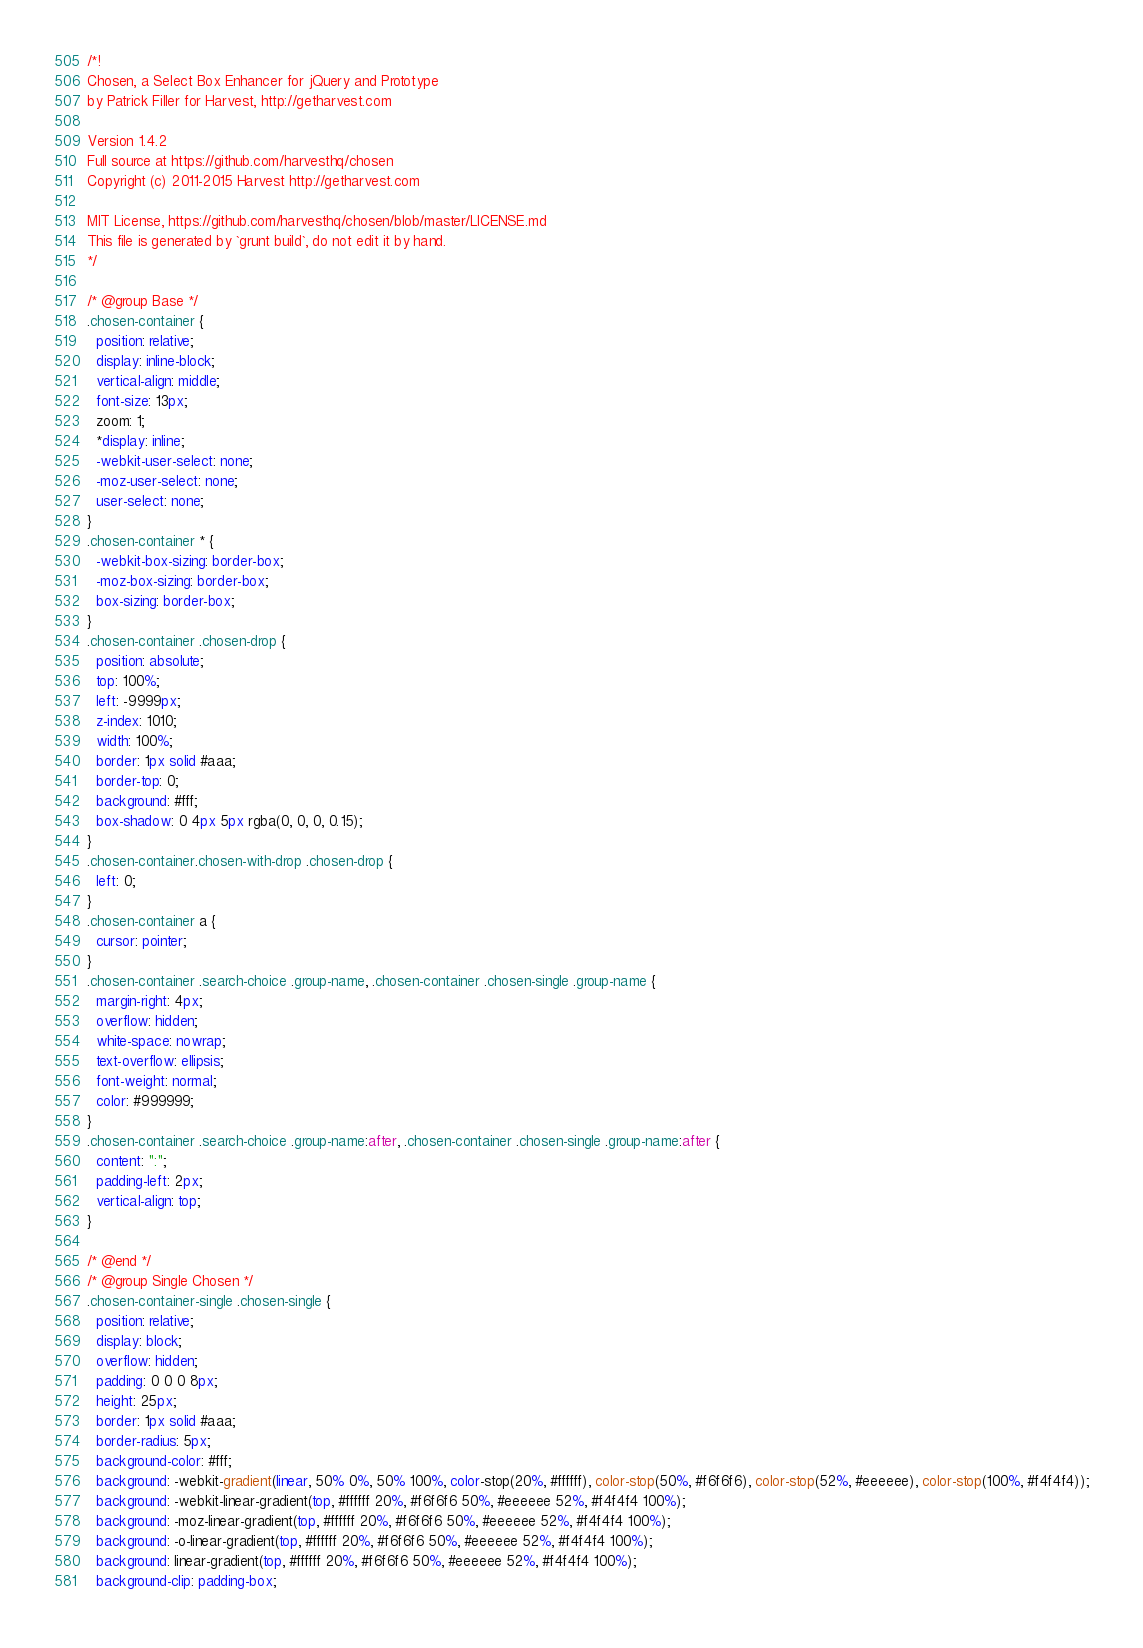Convert code to text. <code><loc_0><loc_0><loc_500><loc_500><_CSS_>/*!
Chosen, a Select Box Enhancer for jQuery and Prototype
by Patrick Filler for Harvest, http://getharvest.com

Version 1.4.2
Full source at https://github.com/harvesthq/chosen
Copyright (c) 2011-2015 Harvest http://getharvest.com

MIT License, https://github.com/harvesthq/chosen/blob/master/LICENSE.md
This file is generated by `grunt build`, do not edit it by hand.
*/

/* @group Base */
.chosen-container {
  position: relative;
  display: inline-block;
  vertical-align: middle;
  font-size: 13px;
  zoom: 1;
  *display: inline;
  -webkit-user-select: none;
  -moz-user-select: none;
  user-select: none;
}
.chosen-container * {
  -webkit-box-sizing: border-box;
  -moz-box-sizing: border-box;
  box-sizing: border-box;
}
.chosen-container .chosen-drop {
  position: absolute;
  top: 100%;
  left: -9999px;
  z-index: 1010;
  width: 100%;
  border: 1px solid #aaa;
  border-top: 0;
  background: #fff;
  box-shadow: 0 4px 5px rgba(0, 0, 0, 0.15);
}
.chosen-container.chosen-with-drop .chosen-drop {
  left: 0;
}
.chosen-container a {
  cursor: pointer;
}
.chosen-container .search-choice .group-name, .chosen-container .chosen-single .group-name {
  margin-right: 4px;
  overflow: hidden;
  white-space: nowrap;
  text-overflow: ellipsis;
  font-weight: normal;
  color: #999999;
}
.chosen-container .search-choice .group-name:after, .chosen-container .chosen-single .group-name:after {
  content: ":";
  padding-left: 2px;
  vertical-align: top;
}

/* @end */
/* @group Single Chosen */
.chosen-container-single .chosen-single {
  position: relative;
  display: block;
  overflow: hidden;
  padding: 0 0 0 8px;
  height: 25px;
  border: 1px solid #aaa;
  border-radius: 5px;
  background-color: #fff;
  background: -webkit-gradient(linear, 50% 0%, 50% 100%, color-stop(20%, #ffffff), color-stop(50%, #f6f6f6), color-stop(52%, #eeeeee), color-stop(100%, #f4f4f4));
  background: -webkit-linear-gradient(top, #ffffff 20%, #f6f6f6 50%, #eeeeee 52%, #f4f4f4 100%);
  background: -moz-linear-gradient(top, #ffffff 20%, #f6f6f6 50%, #eeeeee 52%, #f4f4f4 100%);
  background: -o-linear-gradient(top, #ffffff 20%, #f6f6f6 50%, #eeeeee 52%, #f4f4f4 100%);
  background: linear-gradient(top, #ffffff 20%, #f6f6f6 50%, #eeeeee 52%, #f4f4f4 100%);
  background-clip: padding-box;</code> 